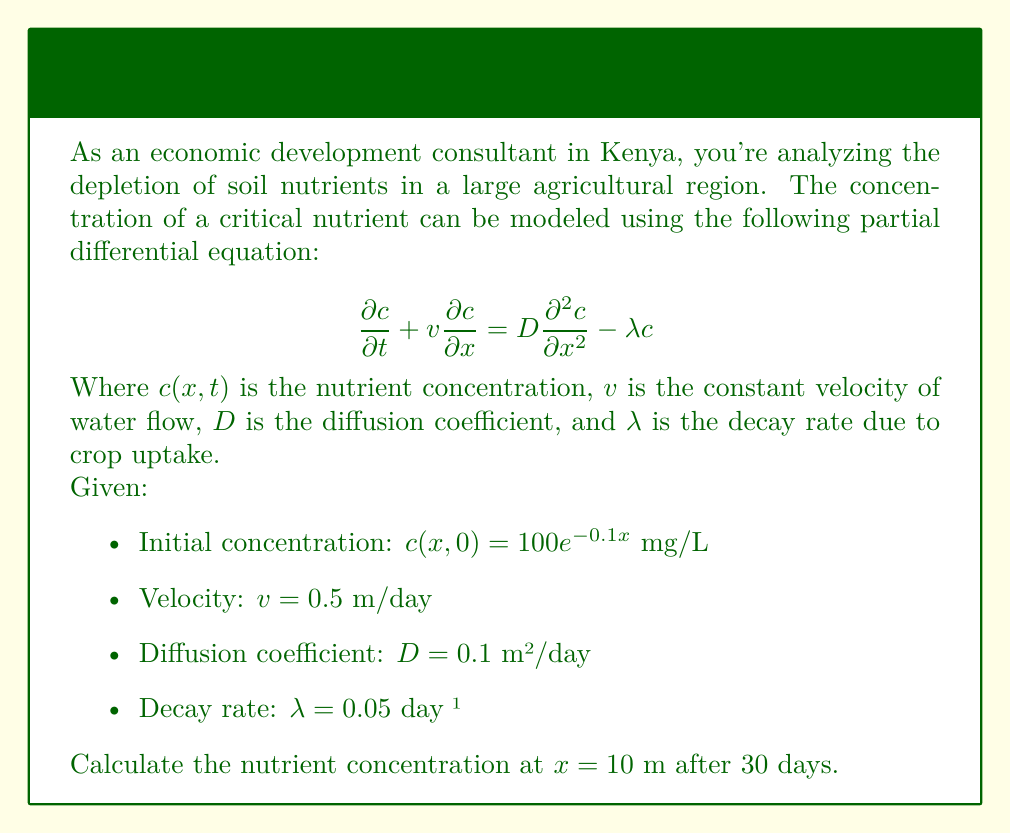Teach me how to tackle this problem. To solve this problem, we need to use the method of separation of variables and Fourier transform. Here's a step-by-step approach:

1) First, we assume a solution of the form:
   $$c(x,t) = X(x)T(t)$$

2) Substituting this into the original PDE:
   $$X(x)T'(t) + vX'(x)T(t) = DX''(x)T(t) - \lambda X(x)T(t)$$

3) Dividing by $X(x)T(t)$:
   $$\frac{T'(t)}{T(t)} + v\frac{X'(x)}{X(x)} = D\frac{X''(x)}{X(x)} - \lambda$$

4) Let $-k^2$ be the separation constant. Then:
   $$\frac{T'(t)}{T(t)} = -k^2 - \lambda$$
   $$D\frac{X''(x)}{X(x)} - v\frac{X'(x)}{X(x)} = -k^2$$

5) Solving for $T(t)$:
   $$T(t) = e^{-(k^2+\lambda)t}$$

6) Solving for $X(x)$:
   $$X(x) = e^{\frac{v}{2D}x}(A\cos(qx) + B\sin(qx))$$
   Where $q = \sqrt{\frac{v^2}{4D^2} + \frac{k^2}{D}}$

7) The general solution is:
   $$c(x,t) = e^{\frac{v}{2D}x-\lambda t}\int_0^\infty [A(k)\cos(qx) + B(k)\sin(qx)]e^{-k^2t}dk$$

8) Using the initial condition:
   $$100e^{-0.1x} = e^{\frac{v}{2D}x}\int_0^\infty [A(k)\cos(qx) + B(k)\sin(qx)]dk$$

9) This is a Fourier transform. Solving for $A(k)$ and $B(k)$:
   $$A(k) = \frac{200D}{(0.1D+0.5)^2 + 4D^2q^2}$$
   $$B(k) = -\frac{100(0.1D+0.5)}{(0.1D+0.5)^2 + 4D^2q^2}$$

10) The final solution is:
    $$c(x,t) = 100e^{\frac{v}{2D}x-\lambda t-0.1(x-vt)}\left[\frac{1}{2}e^{-Dt(\frac{v}{2D}+0.1)^2} + \frac{1}{2}e^{-Dt(\frac{v}{2D}-0.1)^2}\right]$$

11) Substituting the given values and evaluating at $x=10$ and $t=30$:
    $$c(10,30) = 100e^{25-1.5-0.1(10-15)}\left[\frac{1}{2}e^{-3(2.75)^2} + \frac{1}{2}e^{-3(2.25)^2}\right]$$

12) Calculating this expression:
    $$c(10,30) \approx 3.76$$ mg/L
Answer: 3.76 mg/L 